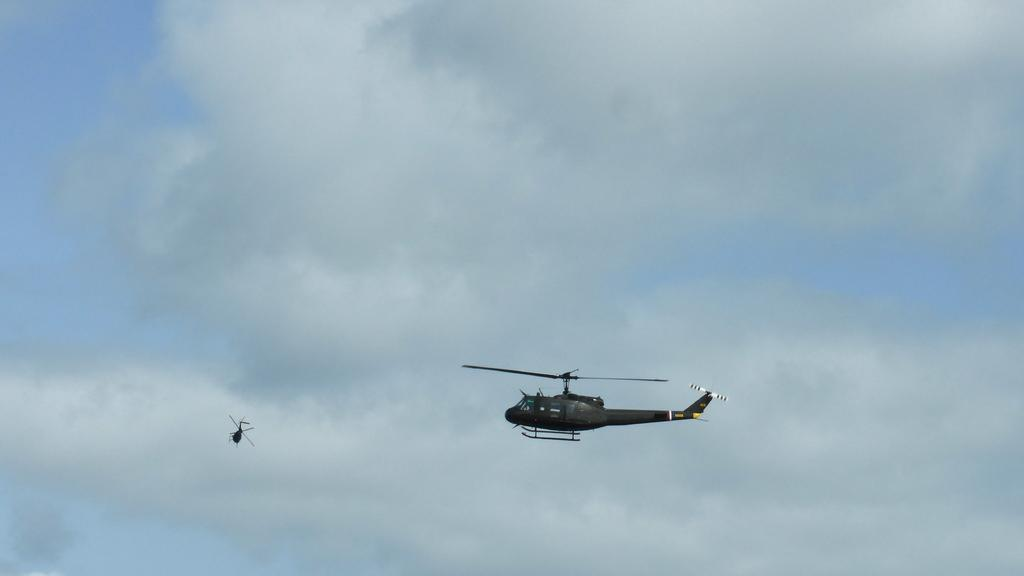What is the main subject of the image? The main subject of the image is two helicopters. What are the helicopters doing in the image? The helicopters are flying in the sky. What can be seen in the background of the image? The sky is visible in the background of the image. How would you describe the weather based on the image? The sky appears to be cloudy, which might suggest overcast or potentially rainy weather. How many dimes can be seen on the helicopter blades in the image? There are no dimes present on the helicopter blades in the image. What type of view can be seen from the helicopters in the image? The image does not provide any information about the view from the helicopters, as it only shows the helicopters flying in the sky. 